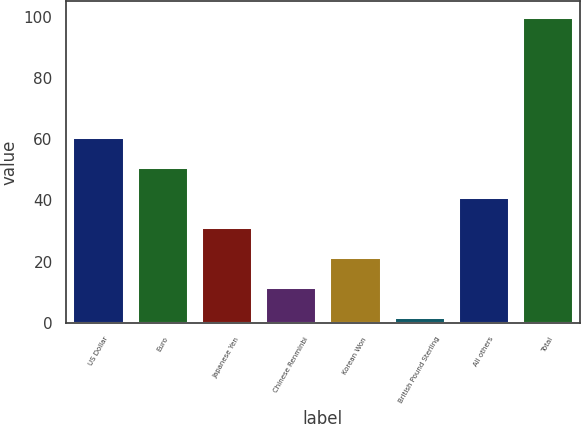<chart> <loc_0><loc_0><loc_500><loc_500><bar_chart><fcel>US Dollar<fcel>Euro<fcel>Japanese Yen<fcel>Chinese Renminbi<fcel>Korean Won<fcel>British Pound Sterling<fcel>All others<fcel>Total<nl><fcel>60.8<fcel>51<fcel>31.4<fcel>11.8<fcel>21.6<fcel>2<fcel>41.2<fcel>100<nl></chart> 